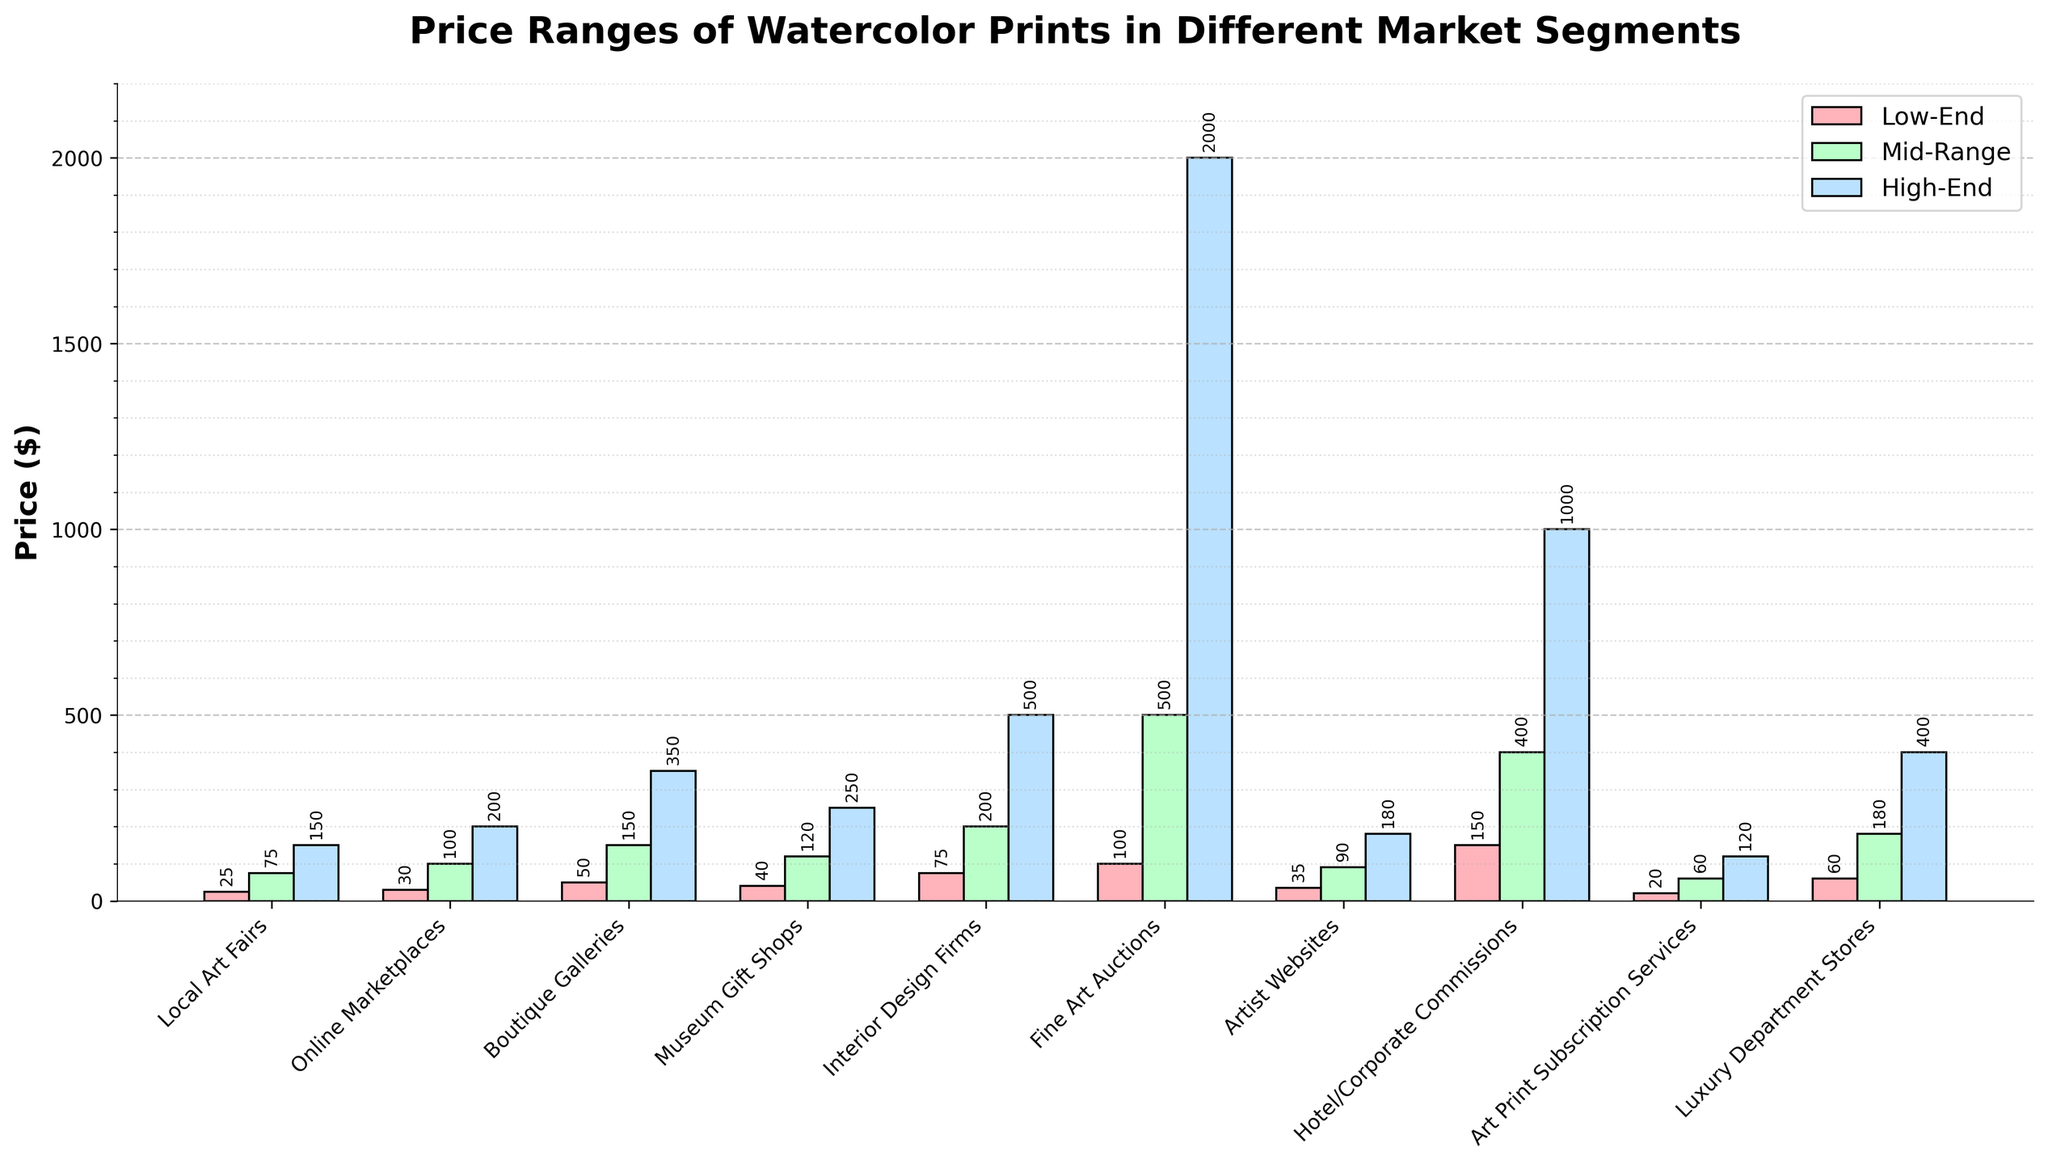Which market segment has the highest high-end price? The bar for the high-end price of the Fine Art Auctions segment is visually the tallest, reaching the top of the plot’s y-axis around $2000.
Answer: Fine Art Auctions What is the price range of watercolor prints in the Museum Gift Shops segment? The low-end price bar for the Museum Gift Shops segment is $40, and the high-end price bar is $250, so the price range is from $40 to $250.
Answer: $40 to $250 Compare the mid-range prices between Boutique Galleries and Online Marketplaces. Which one is higher? Comparing the mid-range price bars of Boutique Galleries and Online Marketplaces, the Boutique Galleries bar is taller and reaches $150, whereas the Online Marketplaces bar reaches $100.
Answer: Boutique Galleries What is the difference between the low-end price of Art Print Subscription Services and the high-end price of Artist Websites? The low-end price bar of Art Print Subscription Services is $20, and the high-end price bar of Artist Websites is $180. Subtracting these, 180 - 20 = 160.
Answer: $160 Which market segment has the lowest mid-range price? The shortest mid-range price bar is for the Art Print Subscription Services segment, reaching $60.
Answer: Art Print Subscription Services Compare the low-end prices between Local Art Fairs and Luxury Department Stores. Which one is lower, and by how much? The low-end price bar for Local Art Fairs is $25, and for Luxury Department Stores it is $60. The difference is 60 - 25 = 35, so Local Art Fairs is lower by $35.
Answer: Local Art Fairs by $35 What is the average high-end price of the Boutique Galleries, Museum Gift Shops, and Luxury Department Stores? The high-end prices for Boutique Galleries, Museum Gift Shops, and Luxury Department Stores are $350, $250, and $400 respectively. Their sum is 350 + 250 + 400 = 1000, and the average is 1000/3 ≈ 333.33.
Answer: $333.33 Are the prices in Hotel/Corporate Commissions more variable than in Interior Design Firms? The price range in Hotel/Corporate Commissions is from $150 to $1000, while in Interior Design Firms it is from $75 to $500. The ranges are 1000 - 150 = 850 for Hotel/Corporate Commissions and 500 - 75 = 425 for Interior Design Firms, so yes, Hotel/Corporate Commissions have a more variable price range.
Answer: Yes Which market segment has a higher mid-range price than low-end price by the largest margin? We need to check the differences between mid-range and low-end prices for each segment. Fine Art Auctions have the mid-range price at $500 and the low-end at $100, so the difference is 500 - 100 = 400, which is the largest among all segments.
Answer: Fine Art Auctions 